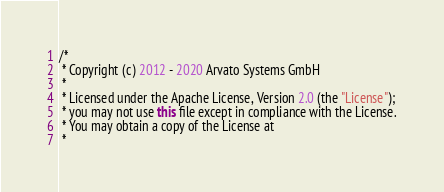<code> <loc_0><loc_0><loc_500><loc_500><_Java_>/*
 * Copyright (c) 2012 - 2020 Arvato Systems GmbH
 *
 * Licensed under the Apache License, Version 2.0 (the "License");
 * you may not use this file except in compliance with the License.
 * You may obtain a copy of the License at
 *</code> 